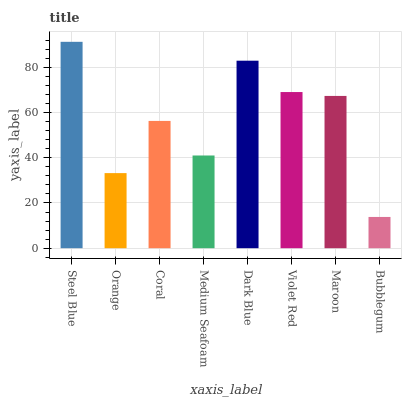Is Bubblegum the minimum?
Answer yes or no. Yes. Is Steel Blue the maximum?
Answer yes or no. Yes. Is Orange the minimum?
Answer yes or no. No. Is Orange the maximum?
Answer yes or no. No. Is Steel Blue greater than Orange?
Answer yes or no. Yes. Is Orange less than Steel Blue?
Answer yes or no. Yes. Is Orange greater than Steel Blue?
Answer yes or no. No. Is Steel Blue less than Orange?
Answer yes or no. No. Is Maroon the high median?
Answer yes or no. Yes. Is Coral the low median?
Answer yes or no. Yes. Is Steel Blue the high median?
Answer yes or no. No. Is Bubblegum the low median?
Answer yes or no. No. 